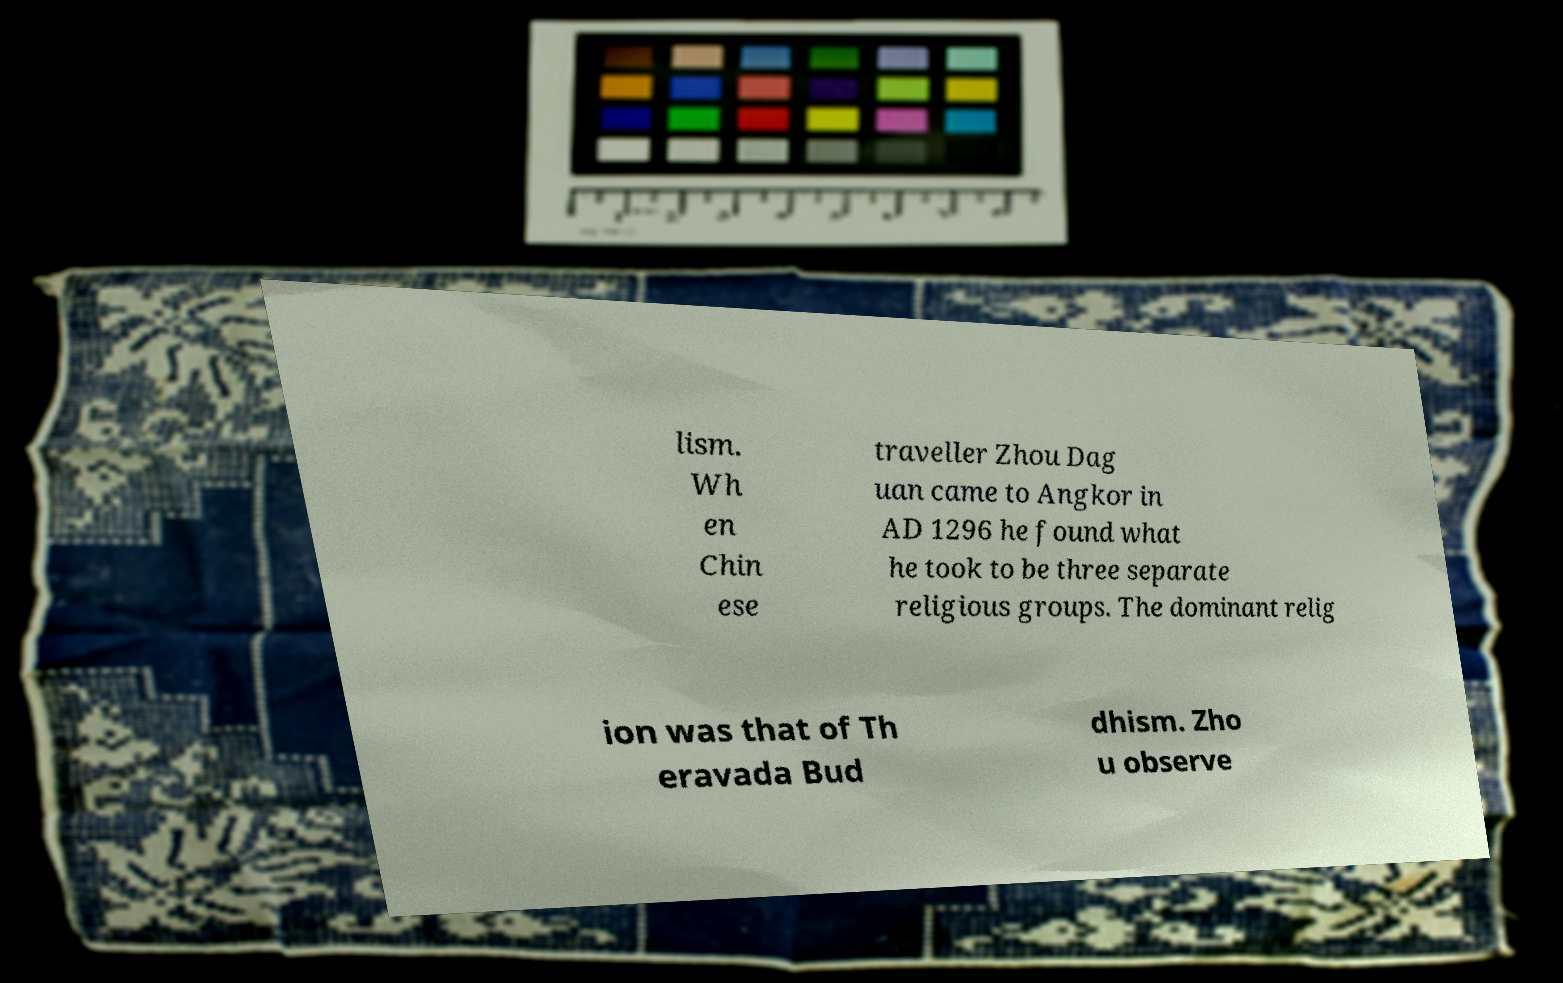I need the written content from this picture converted into text. Can you do that? lism. Wh en Chin ese traveller Zhou Dag uan came to Angkor in AD 1296 he found what he took to be three separate religious groups. The dominant relig ion was that of Th eravada Bud dhism. Zho u observe 